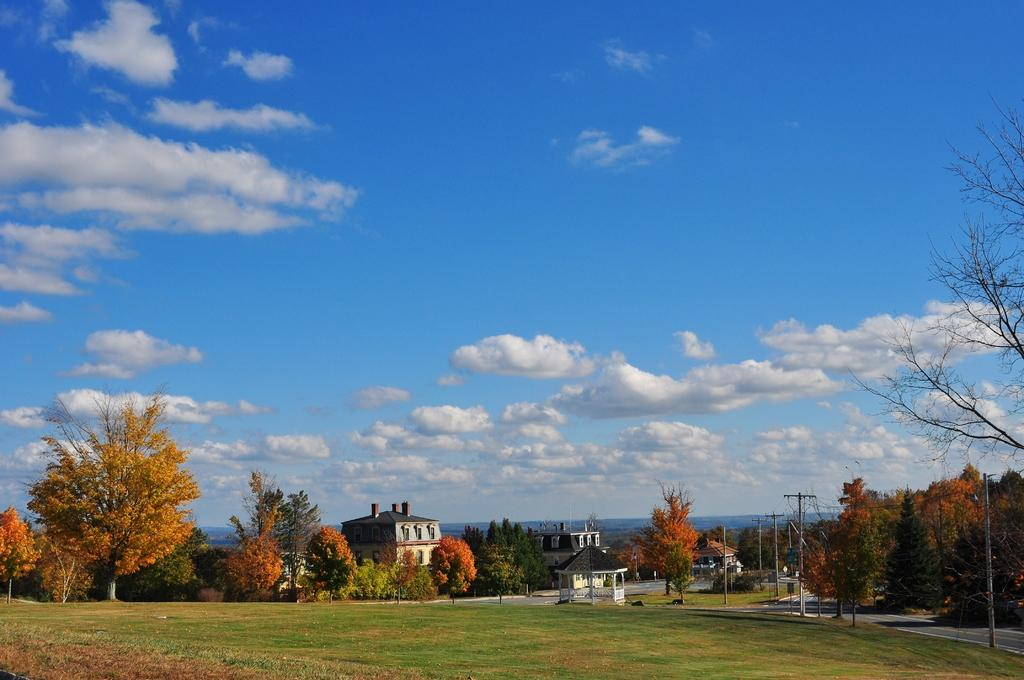What type of vegetation is at the bottom of the image? There is grass at the bottom of the image. What other objects can be seen at the bottom of the image? There are poles, trees, and buildings at the bottom of the image. What is visible at the top of the image? There are clouds and the sky visible at the top of the image. What type of reaction does the doll have to the organization in the image? There is no doll present in the image, so it is not possible to answer that question. 